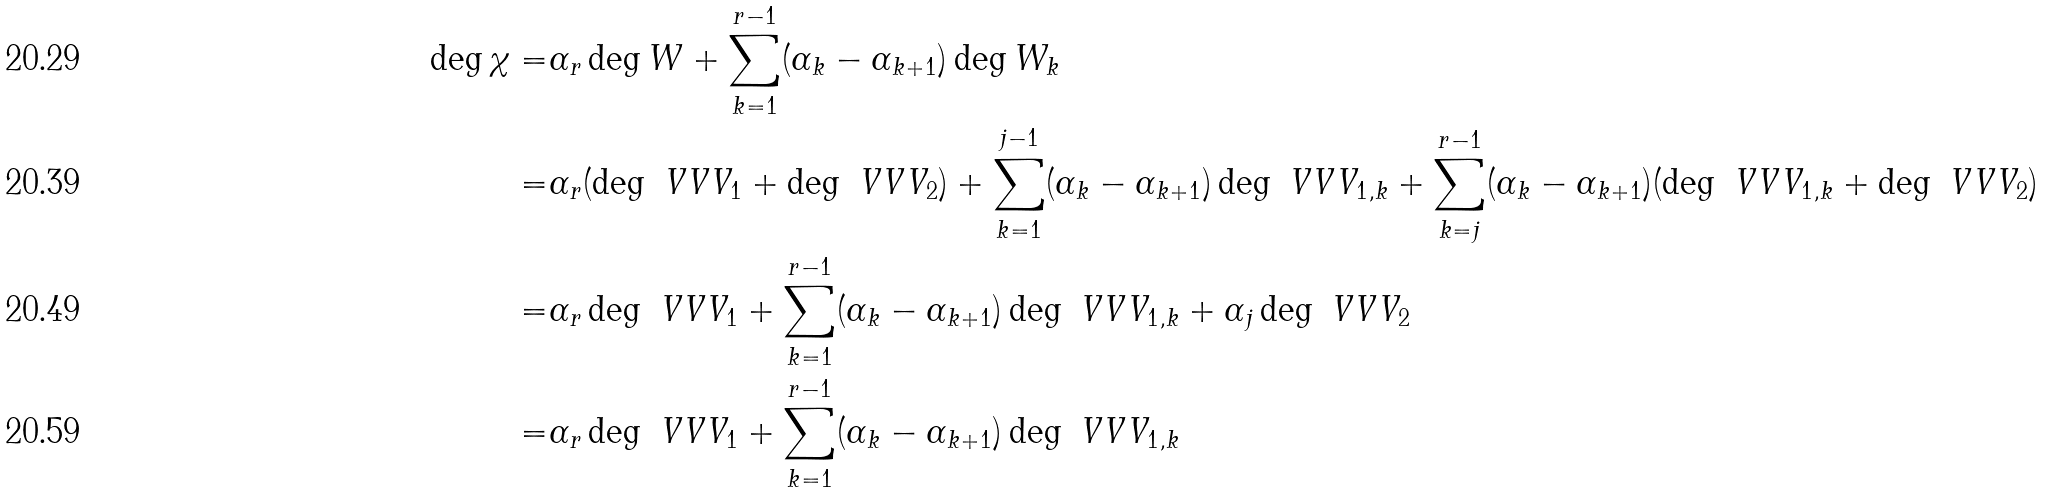<formula> <loc_0><loc_0><loc_500><loc_500>\deg \chi = & \alpha _ { r } \deg W + \sum _ { k = 1 } ^ { r - 1 } ( \alpha _ { k } - \alpha _ { k + 1 } ) \deg W _ { k } \\ = & \alpha _ { r } ( \deg \ V V V _ { 1 } + \deg \ V V V _ { 2 } ) + \sum _ { k = 1 } ^ { j - 1 } ( \alpha _ { k } - \alpha _ { k + 1 } ) \deg \ V V V _ { 1 , k } + \sum _ { k = j } ^ { r - 1 } ( \alpha _ { k } - \alpha _ { k + 1 } ) ( \deg \ V V V _ { 1 , k } + \deg \ V V V _ { 2 } ) \\ = & \alpha _ { r } \deg \ V V V _ { 1 } + \sum _ { k = 1 } ^ { r - 1 } ( \alpha _ { k } - \alpha _ { k + 1 } ) \deg \ V V V _ { 1 , k } + \alpha _ { j } \deg \ V V V _ { 2 } \\ = & \alpha _ { r } \deg \ V V V _ { 1 } + \sum _ { k = 1 } ^ { r - 1 } ( \alpha _ { k } - \alpha _ { k + 1 } ) \deg \ V V V _ { 1 , k }</formula> 